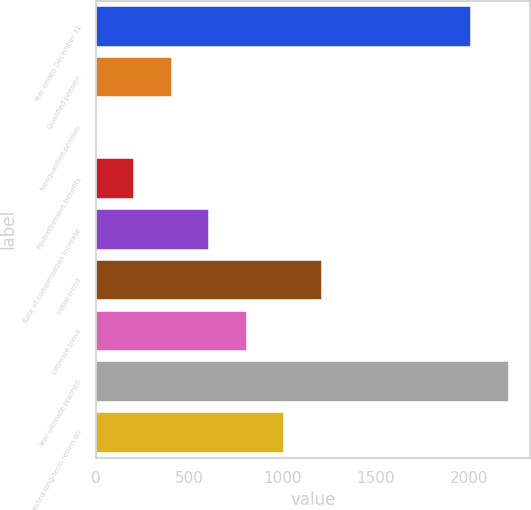Convert chart to OTSL. <chart><loc_0><loc_0><loc_500><loc_500><bar_chart><fcel>Year ended December 31<fcel>Qualified pension<fcel>Nonqualified pension<fcel>Postretirement benefits<fcel>Rate of compensation increase<fcel>Initial trend<fcel>Ultimate trend<fcel>Year ultimate reached<fcel>Expected long-term return on<nl><fcel>2013<fcel>406.56<fcel>3.45<fcel>205<fcel>608.12<fcel>1212.78<fcel>809.67<fcel>2214.55<fcel>1011.22<nl></chart> 